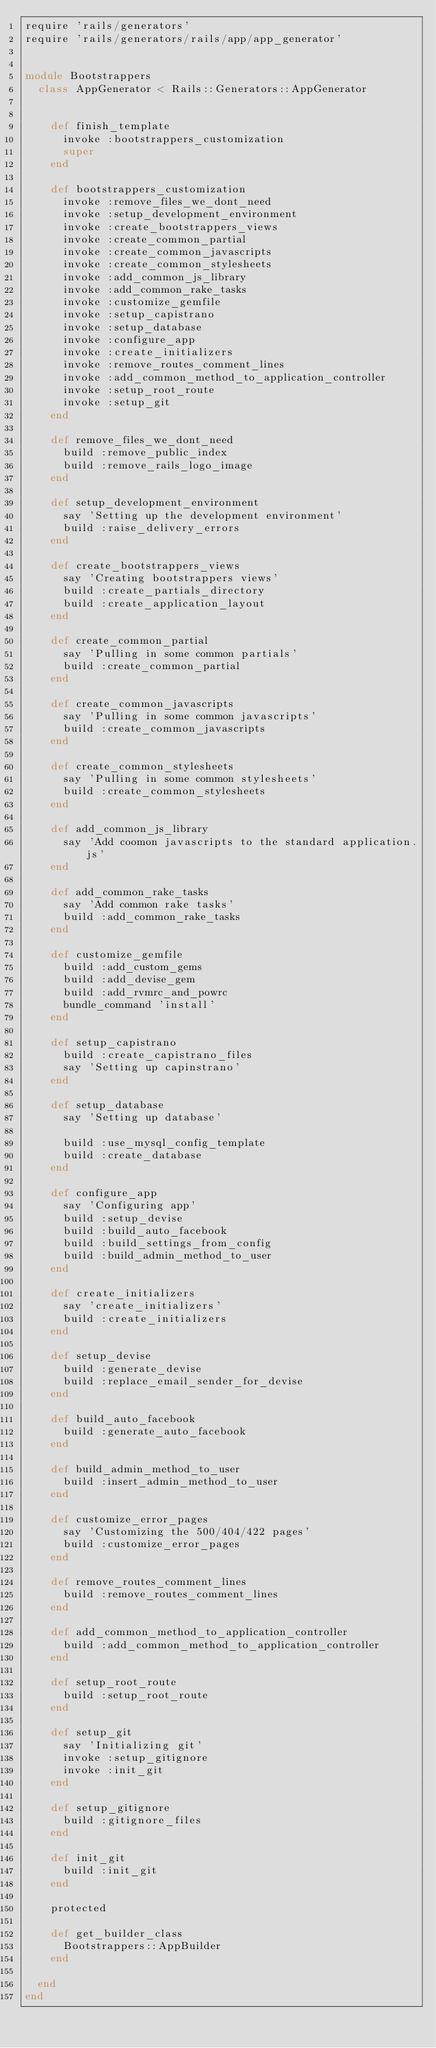Convert code to text. <code><loc_0><loc_0><loc_500><loc_500><_Ruby_>require 'rails/generators'
require 'rails/generators/rails/app/app_generator'


module Bootstrappers
  class AppGenerator < Rails::Generators::AppGenerator


    def finish_template
      invoke :bootstrappers_customization
      super
    end

    def bootstrappers_customization
      invoke :remove_files_we_dont_need
      invoke :setup_development_environment
      invoke :create_bootstrappers_views
      invoke :create_common_partial
      invoke :create_common_javascripts
      invoke :create_common_stylesheets
      invoke :add_common_js_library
      invoke :add_common_rake_tasks
      invoke :customize_gemfile
      invoke :setup_capistrano
      invoke :setup_database
      invoke :configure_app
      invoke :create_initializers
      invoke :remove_routes_comment_lines
      invoke :add_common_method_to_application_controller
      invoke :setup_root_route
      invoke :setup_git
    end

    def remove_files_we_dont_need
      build :remove_public_index
      build :remove_rails_logo_image
    end

    def setup_development_environment
      say 'Setting up the development environment'
      build :raise_delivery_errors
    end

    def create_bootstrappers_views
      say 'Creating bootstrappers views'
      build :create_partials_directory
      build :create_application_layout
    end

    def create_common_partial
      say 'Pulling in some common partials'
      build :create_common_partial
    end

    def create_common_javascripts
      say 'Pulling in some common javascripts'
      build :create_common_javascripts
    end

    def create_common_stylesheets
      say 'Pulling in some common stylesheets'
      build :create_common_stylesheets
    end

    def add_common_js_library
      say 'Add coomon javascripts to the standard application.js'
    end

    def add_common_rake_tasks
      say 'Add common rake tasks'
      build :add_common_rake_tasks
    end

    def customize_gemfile
      build :add_custom_gems
      build :add_devise_gem
      build :add_rvmrc_and_powrc
      bundle_command 'install'
    end

    def setup_capistrano
      build :create_capistrano_files
      say 'Setting up capinstrano'
    end

    def setup_database
      say 'Setting up database'

      build :use_mysql_config_template
      build :create_database
    end

    def configure_app
      say 'Configuring app'
      build :setup_devise
      build :build_auto_facebook
      build :build_settings_from_config
      build :build_admin_method_to_user
    end

    def create_initializers
      say 'create_initializers'
      build :create_initializers
    end

    def setup_devise
      build :generate_devise
      build :replace_email_sender_for_devise
    end

    def build_auto_facebook
      build :generate_auto_facebook
    end

    def build_admin_method_to_user
      build :insert_admin_method_to_user
    end

    def customize_error_pages
      say 'Customizing the 500/404/422 pages'
      build :customize_error_pages
    end

    def remove_routes_comment_lines
      build :remove_routes_comment_lines
    end

    def add_common_method_to_application_controller
      build :add_common_method_to_application_controller
    end

    def setup_root_route
      build :setup_root_route
    end

    def setup_git
      say 'Initializing git'
      invoke :setup_gitignore
      invoke :init_git
    end

    def setup_gitignore
      build :gitignore_files
    end

    def init_git
      build :init_git
    end

    protected

    def get_builder_class
      Bootstrappers::AppBuilder
    end

  end
end
</code> 